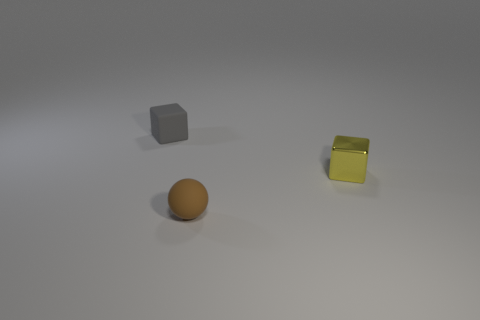Is there any other thing that is the same shape as the small brown thing?
Ensure brevity in your answer.  No. What is the color of the shiny thing?
Ensure brevity in your answer.  Yellow. There is a rubber thing that is left of the brown matte thing; is its size the same as the rubber thing in front of the small yellow object?
Your response must be concise. Yes. Are there fewer balls than tiny cubes?
Your answer should be compact. Yes. What number of rubber spheres are left of the brown matte object?
Offer a terse response. 0. What material is the gray block?
Keep it short and to the point. Rubber. Is the number of small yellow shiny things in front of the brown matte thing less than the number of tiny yellow cylinders?
Provide a short and direct response. No. There is a small rubber object that is in front of the gray matte object; what is its color?
Your answer should be compact. Brown. What shape is the tiny brown matte thing?
Your answer should be very brief. Sphere. There is a cube left of the small rubber object that is on the right side of the gray cube; are there any small brown matte objects in front of it?
Offer a terse response. Yes. 